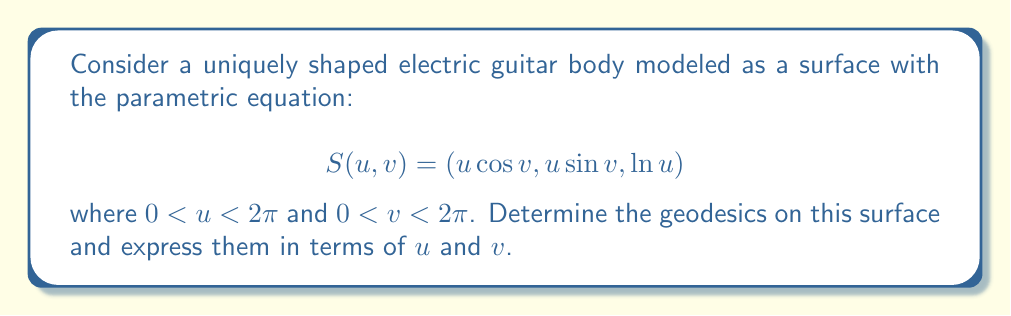Can you solve this math problem? To find the geodesics on this surface, we'll follow these steps:

1) First, we need to calculate the coefficients of the first fundamental form:

   $E = \left(\frac{\partial S}{\partial u}\right)^2 = \cos^2 v + \sin^2 v + \frac{1}{u^2} = 1 + \frac{1}{u^2}$
   $F = \frac{\partial S}{\partial u} \cdot \frac{\partial S}{\partial v} = -u\sin v \cos v + u\cos v \sin v = 0$
   $G = \left(\frac{\partial S}{\partial v}\right)^2 = u^2\sin^2 v + u^2\cos^2 v = u^2$

2) The geodesic equations are:

   $$\frac{d^2u}{ds^2} + \Gamma^u_{uu}\left(\frac{du}{ds}\right)^2 + 2\Gamma^u_{uv}\frac{du}{ds}\frac{dv}{ds} + \Gamma^u_{vv}\left(\frac{dv}{ds}\right)^2 = 0$$
   $$\frac{d^2v}{ds^2} + \Gamma^v_{uu}\left(\frac{du}{ds}\right)^2 + 2\Gamma^v_{uv}\frac{du}{ds}\frac{dv}{ds} + \Gamma^v_{vv}\left(\frac{dv}{ds}\right)^2 = 0$$

3) Calculate the Christoffel symbols:

   $\Gamma^u_{uu} = \frac{G_u}{2E} = \frac{u}{1+\frac{1}{u^2}} = \frac{u^3}{1+u^2}$
   $\Gamma^u_{uv} = \Gamma^u_{vu} = 0$
   $\Gamma^u_{vv} = -\frac{EG_v-FE_v}{2E^2} = -\frac{u^3}{1+u^2}$
   $\Gamma^v_{uu} = -\frac{G_u}{2G} = -\frac{1}{u}$
   $\Gamma^v_{uv} = \Gamma^v_{vu} = \frac{1}{u}$
   $\Gamma^v_{vv} = 0$

4) Substitute these into the geodesic equations:

   $$\frac{d^2u}{ds^2} + \frac{u^3}{1+u^2}\left(\frac{du}{ds}\right)^2 - \frac{u^3}{1+u^2}\left(\frac{dv}{ds}\right)^2 = 0$$
   $$\frac{d^2v}{ds^2} - \frac{1}{u}\left(\frac{du}{ds}\right)^2 + \frac{2}{u}\frac{du}{ds}\frac{dv}{ds} = 0$$

5) These equations describe the geodesics on the surface. They can be solved numerically for specific initial conditions.

6) One special case of geodesics can be found analytically: when $u$ is constant. In this case, $\frac{du}{ds} = 0$ and $\frac{d^2u}{ds^2} = 0$, and the equations reduce to:

   $$\frac{u^3}{1+u^2}\left(\frac{dv}{ds}\right)^2 = 0$$
   $$\frac{d^2v}{ds^2} = 0$$

   This implies $v = as + b$ for constants $a$ and $b$, representing circular geodesics around the axis of symmetry.
Answer: Geodesics satisfy: $\frac{d^2u}{ds^2} + \frac{u^3}{1+u^2}\left(\frac{du}{ds}\right)^2 - \frac{u^3}{1+u^2}\left(\frac{dv}{ds}\right)^2 = 0$ and $\frac{d^2v}{ds^2} - \frac{1}{u}\left(\frac{du}{ds}\right)^2 + \frac{2}{u}\frac{du}{ds}\frac{dv}{ds} = 0$. Special case: $u = const$, $v = as + b$. 